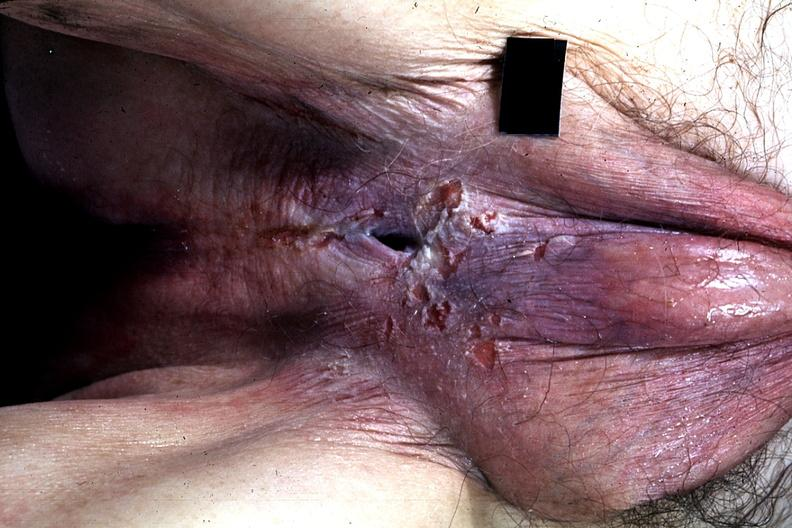what is present?
Answer the question using a single word or phrase. Penis 